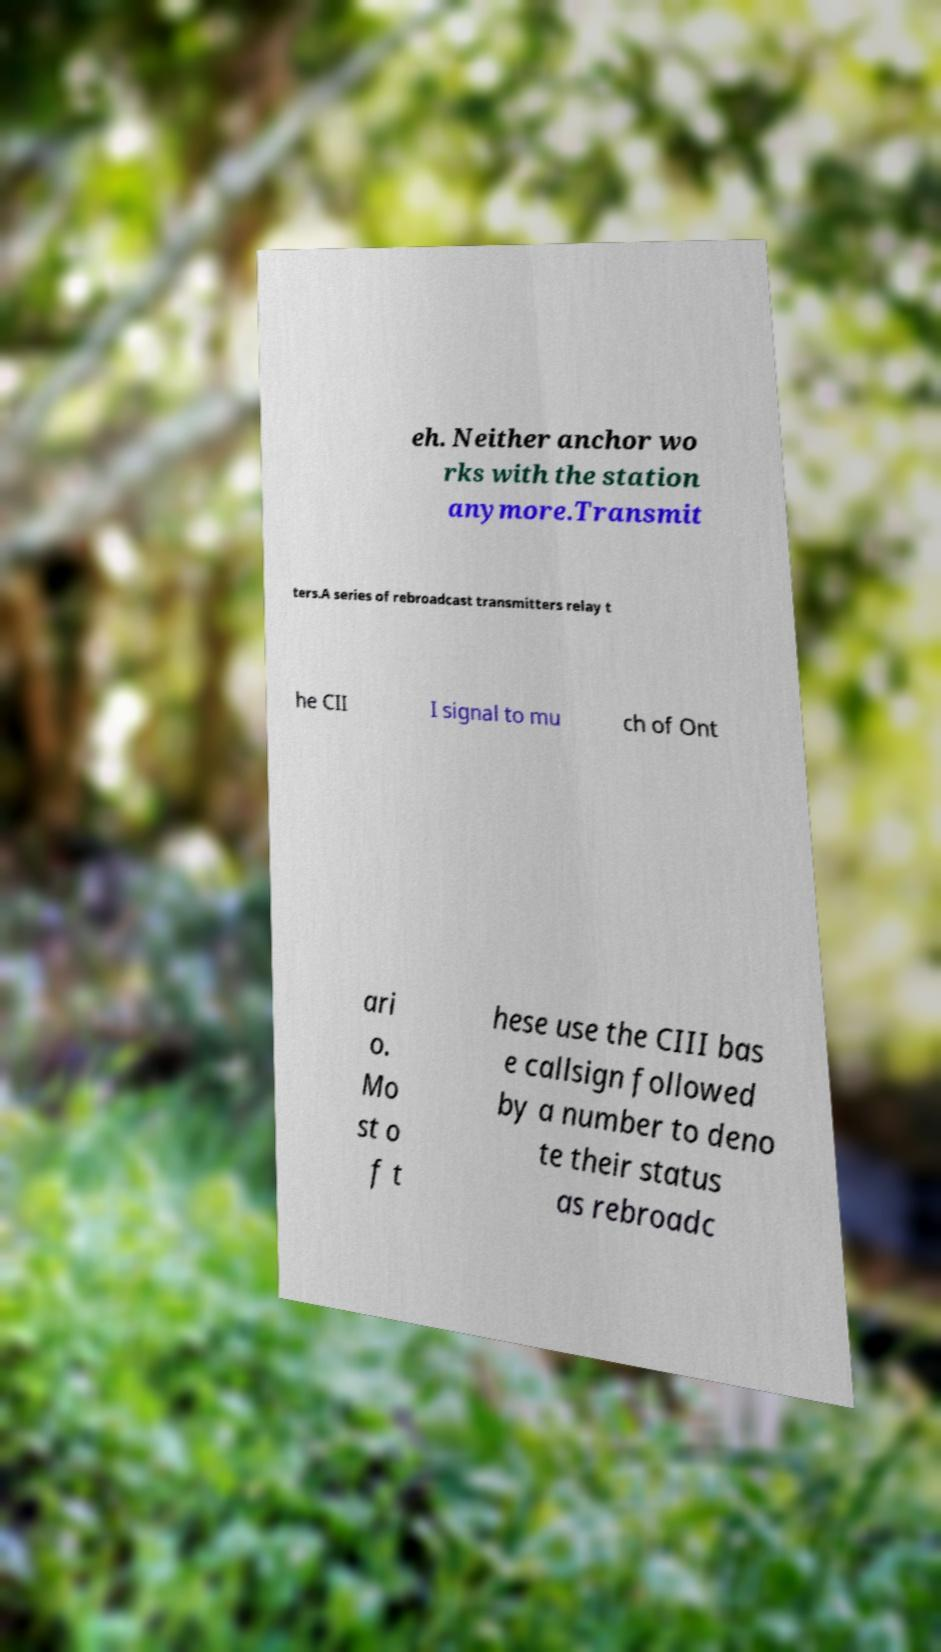For documentation purposes, I need the text within this image transcribed. Could you provide that? eh. Neither anchor wo rks with the station anymore.Transmit ters.A series of rebroadcast transmitters relay t he CII I signal to mu ch of Ont ari o. Mo st o f t hese use the CIII bas e callsign followed by a number to deno te their status as rebroadc 